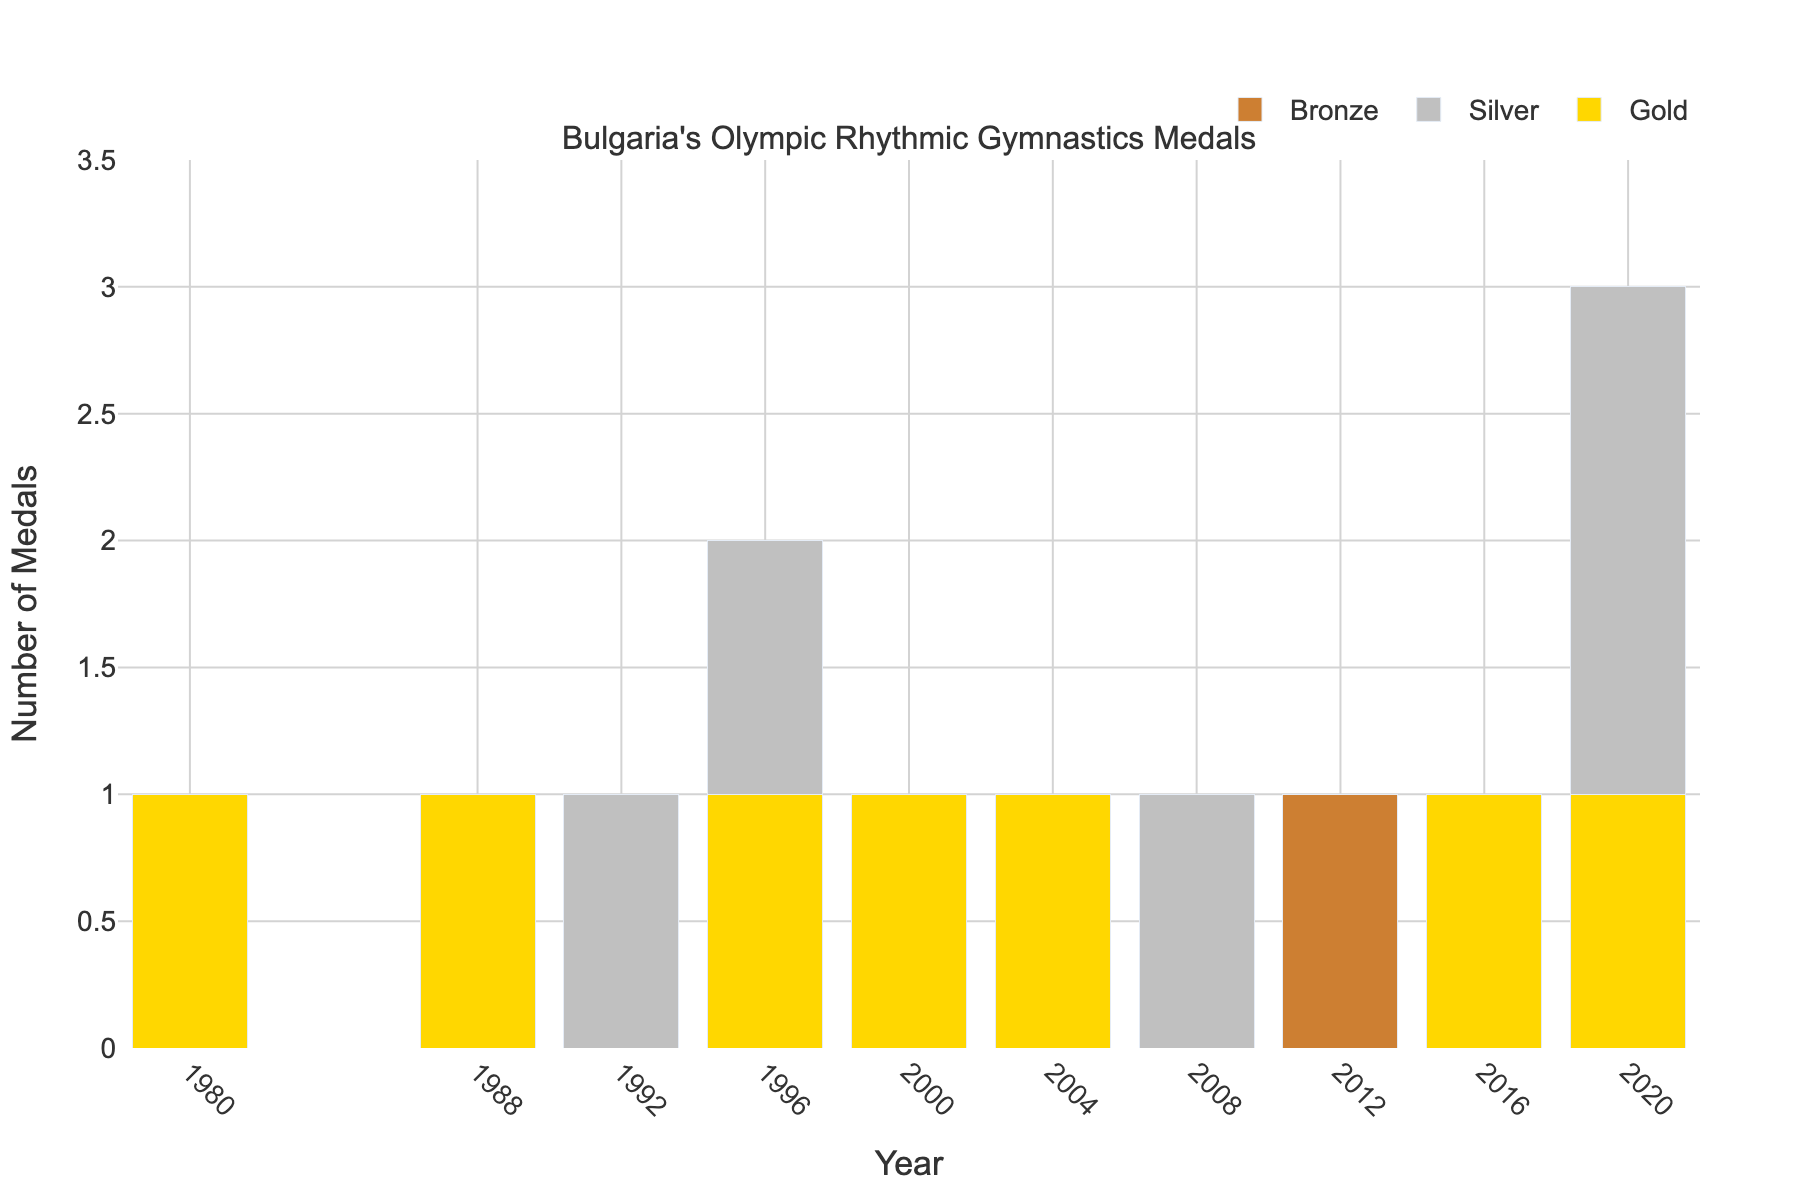What's the total number of Gold medals Bulgaria has won in rhythmic gymnastics? Sum all the Gold medal counts from each year. The totals are: 1 (1980) + 1 (1988) + 0 (1992) + 1 (1996) + 1 (2000) + 1 (2004) + 0 (2008) + 0 (2012) + 1 (2016) + 1 (2020) = 7
Answer: 7 How many Silver medals did Bulgaria win in the 1996 Olympics? Refer to the Silver medal count specifically for the year 1996. The count is 1.
Answer: 1 In which year did Bulgaria win the most total medals in rhythmic gymnastics? Sum the Gold, Silver, and Bronze medals for each year and compare. The year with the highest total is 2020 (1 Gold + 2 Silver + 0 Bronze = 3 total medals).
Answer: 2020 Which type of medal has Bulgaria won the least number of times in rhythmic gymnastics? Compare the total counts for Gold, Silver, and Bronze medals. The totals are: Gold = 7, Silver = 4, Bronze = 1. Thus, Bronze is the least.
Answer: Bronze How many years did Bulgaria win exactly one medal in rhythmic gymnastics? Count the number of years where the total medals (Gold + Silver + Bronze) is exactly 1. These years are 1980 (1 Gold), 1988 (1 Gold), 1992 (1 Silver), 2000 (1 Gold), 2004 (1 Gold), 2008 (1 Silver), 2012 (1 Bronze). Total count = 7.
Answer: 7 Which years did Bulgaria win both Gold and Silver medals in rhythmic gymnastics? Identify the years where both Gold and Silver medals are greater than 0. The only such year is 1996.
Answer: 1996 Did Bulgaria win more total medals in rhythmic gymnastics before 2000 or after 2000? Sum the total medals (Gold + Silver + Bronze) before 2000 and after 2000. Before 2000: 1(1980) + 1(1988) + 1(1992) + 2(1996) = 5. After 2000: 1(2000) + 1(2004) + 1(2008) + 1(2012) + 1(2016) + 3(2020) = 8.
Answer: After 2000 In which year did Bulgaria win its only Bronze medal in rhythmic gymnastics? Refer to the Bronze medal column and identify the year with one Bronze medal. The year is 2012.
Answer: 2012 How many total medals did Bulgaria win from 1980 to 2000? Sum the total medals (Gold + Silver + Bronze) for the years 1980, 1988, 1992, 1996, and 2000. The counts are 1+1+1+2+1=6.
Answer: 6 